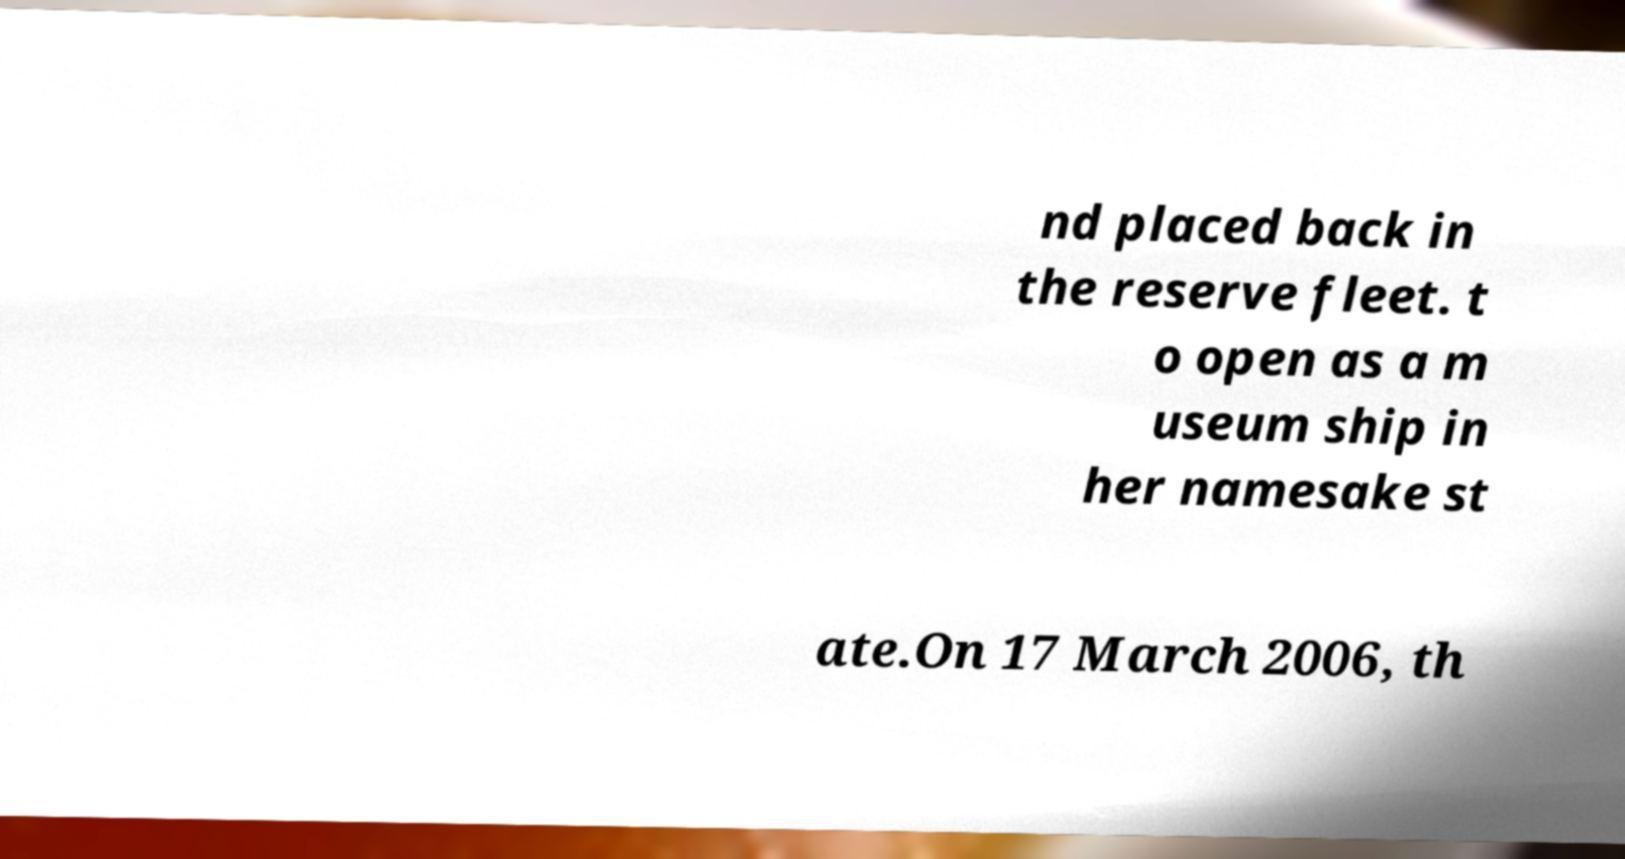Please read and relay the text visible in this image. What does it say? nd placed back in the reserve fleet. t o open as a m useum ship in her namesake st ate.On 17 March 2006, th 